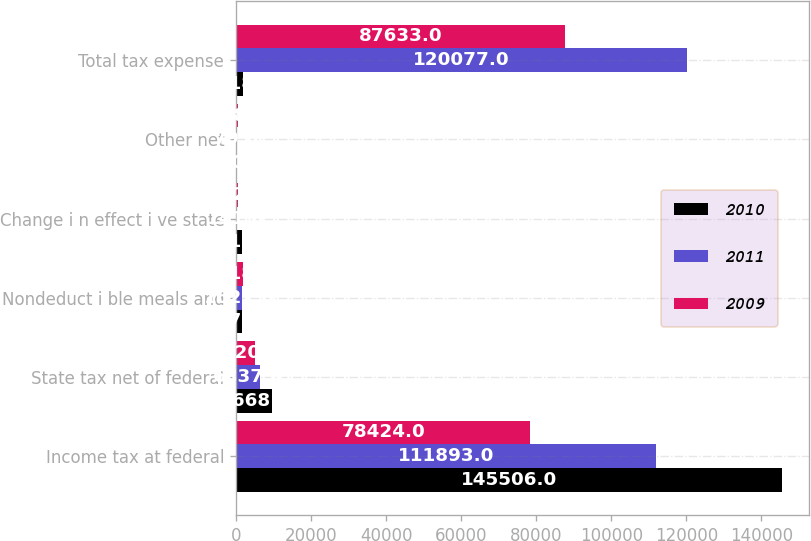Convert chart to OTSL. <chart><loc_0><loc_0><loc_500><loc_500><stacked_bar_chart><ecel><fcel>Income tax at federal<fcel>State tax net of federal<fcel>Nondeduct i ble meals and<fcel>Change i n effect i ve state<fcel>Other net<fcel>Total tax expense<nl><fcel>2010<fcel>145506<fcel>9668<fcel>1570<fcel>1611<fcel>180<fcel>1818<nl><fcel>2011<fcel>111893<fcel>6337<fcel>1627<fcel>141<fcel>79<fcel>120077<nl><fcel>2009<fcel>78424<fcel>5020<fcel>1818<fcel>592<fcel>418<fcel>87633<nl></chart> 